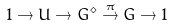<formula> <loc_0><loc_0><loc_500><loc_500>1 \to U \to G ^ { \diamond } \overset { \pi } { \to } G \to 1</formula> 